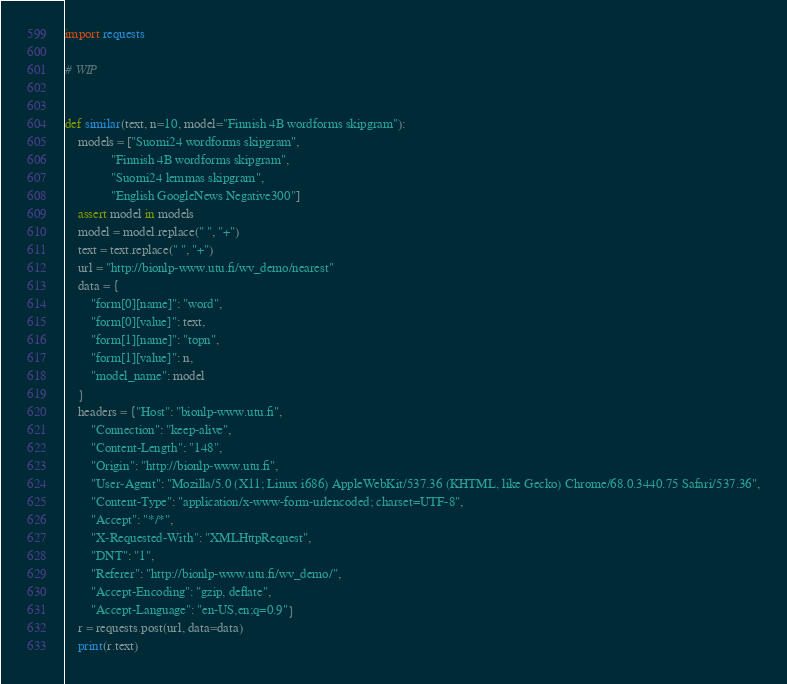<code> <loc_0><loc_0><loc_500><loc_500><_Python_>import requests

# WIP


def similar(text, n=10, model="Finnish 4B wordforms skipgram"):
    models = ["Suomi24 wordforms skipgram",
              "Finnish 4B wordforms skipgram",
              "Suomi24 lemmas skipgram",
              "English GoogleNews Negative300"]
    assert model in models
    model = model.replace(" ", "+")
    text = text.replace(" ", "+")
    url = "http://bionlp-www.utu.fi/wv_demo/nearest"
    data = {
        "form[0][name]": "word",
        "form[0][value]": text,
        "form[1][name]": "topn",
        "form[1][value]": n,
        "model_name": model
    }
    headers = {"Host": "bionlp-www.utu.fi",
        "Connection": "keep-alive",
        "Content-Length": "148",
        "Origin": "http://bionlp-www.utu.fi",
        "User-Agent": "Mozilla/5.0 (X11; Linux i686) AppleWebKit/537.36 (KHTML, like Gecko) Chrome/68.0.3440.75 Safari/537.36",
        "Content-Type": "application/x-www-form-urlencoded; charset=UTF-8",
        "Accept": "*/*",
        "X-Requested-With": "XMLHttpRequest",
        "DNT": "1",
        "Referer": "http://bionlp-www.utu.fi/wv_demo/",
        "Accept-Encoding": "gzip, deflate",
        "Accept-Language": "en-US,en;q=0.9"}
    r = requests.post(url, data=data)
    print(r.text)</code> 